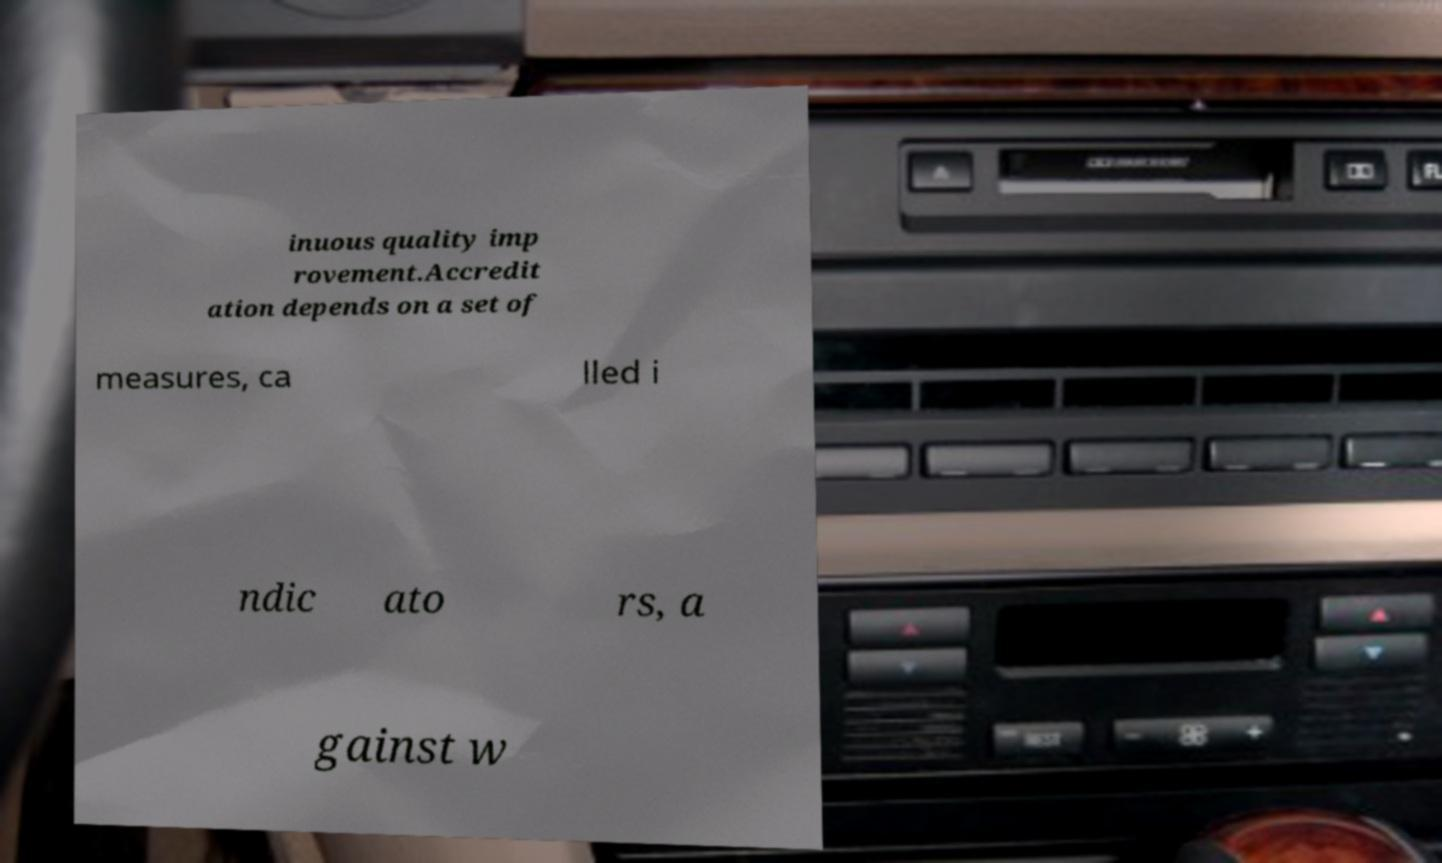Can you accurately transcribe the text from the provided image for me? inuous quality imp rovement.Accredit ation depends on a set of measures, ca lled i ndic ato rs, a gainst w 